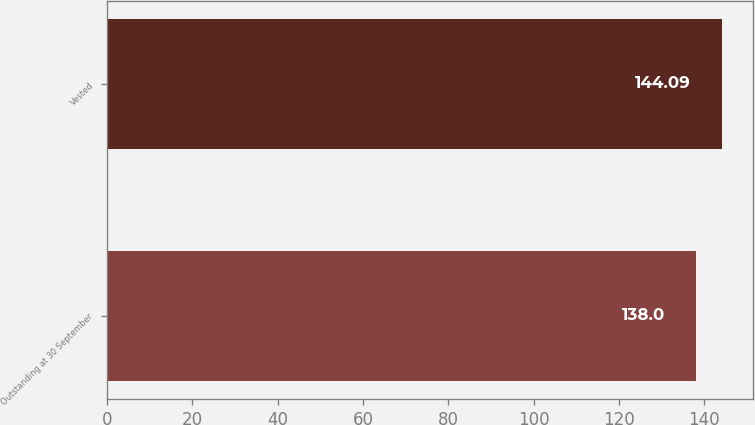Convert chart. <chart><loc_0><loc_0><loc_500><loc_500><bar_chart><fcel>Outstanding at 30 September<fcel>Vested<nl><fcel>138<fcel>144.09<nl></chart> 